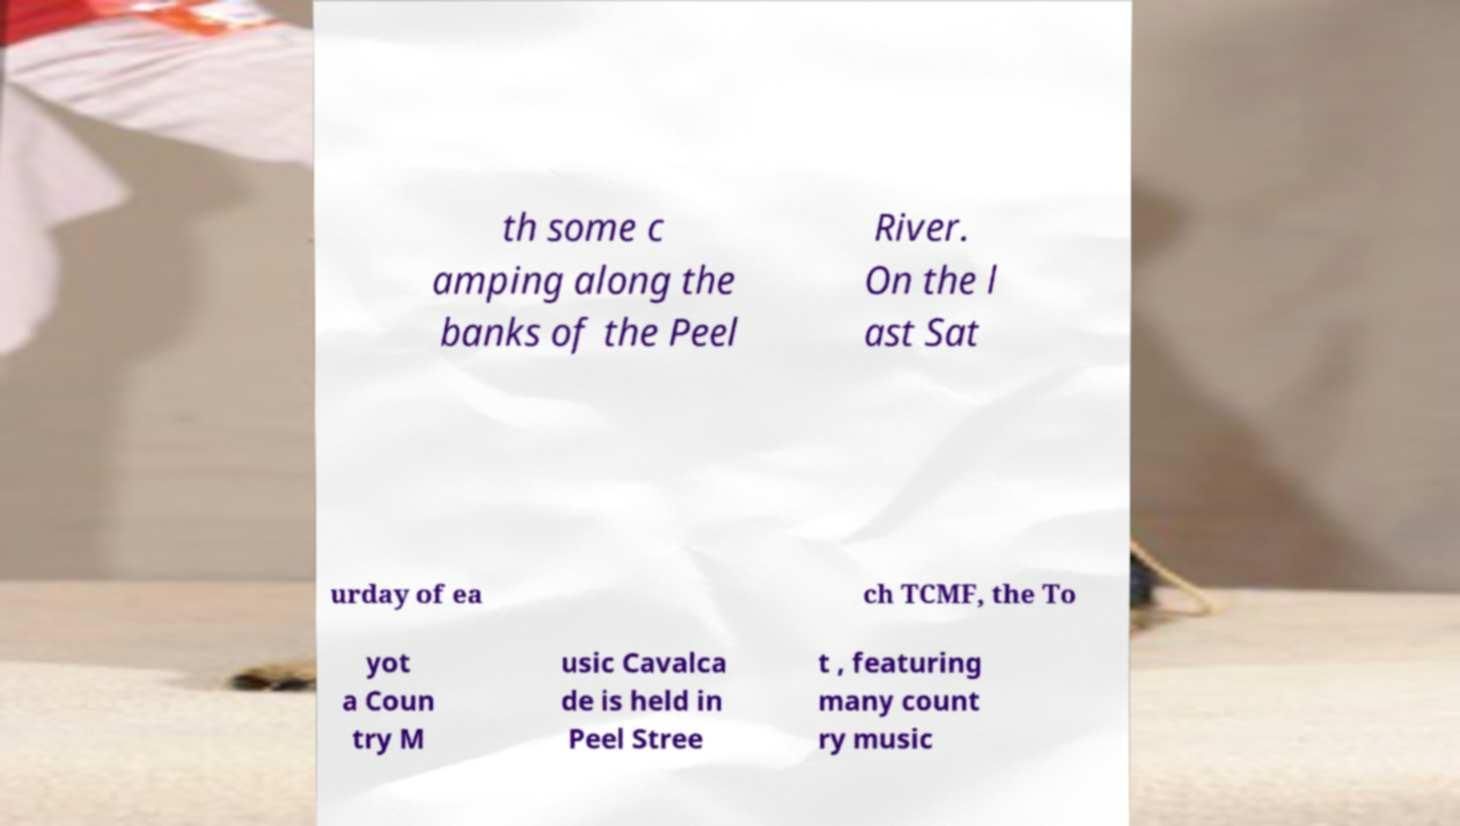Can you accurately transcribe the text from the provided image for me? th some c amping along the banks of the Peel River. On the l ast Sat urday of ea ch TCMF, the To yot a Coun try M usic Cavalca de is held in Peel Stree t , featuring many count ry music 